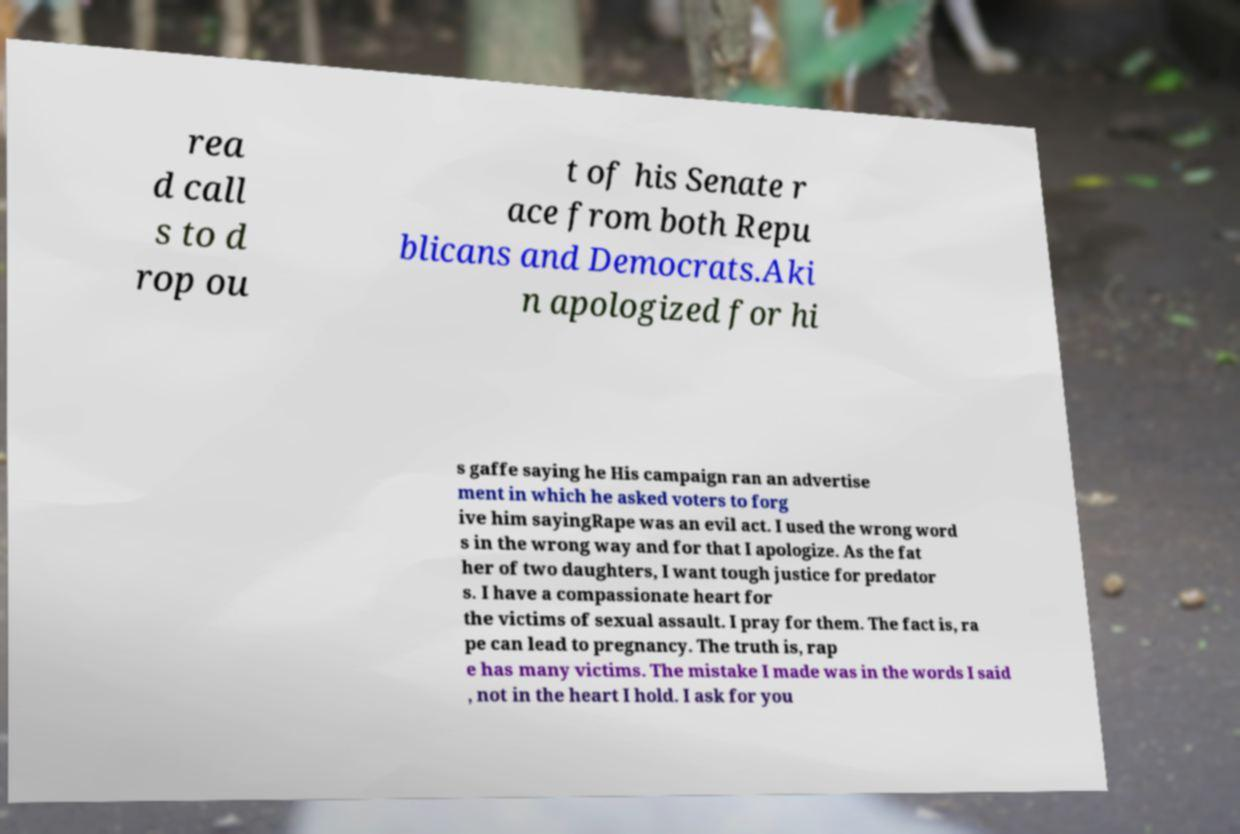I need the written content from this picture converted into text. Can you do that? rea d call s to d rop ou t of his Senate r ace from both Repu blicans and Democrats.Aki n apologized for hi s gaffe saying he His campaign ran an advertise ment in which he asked voters to forg ive him sayingRape was an evil act. I used the wrong word s in the wrong way and for that I apologize. As the fat her of two daughters, I want tough justice for predator s. I have a compassionate heart for the victims of sexual assault. I pray for them. The fact is, ra pe can lead to pregnancy. The truth is, rap e has many victims. The mistake I made was in the words I said , not in the heart I hold. I ask for you 